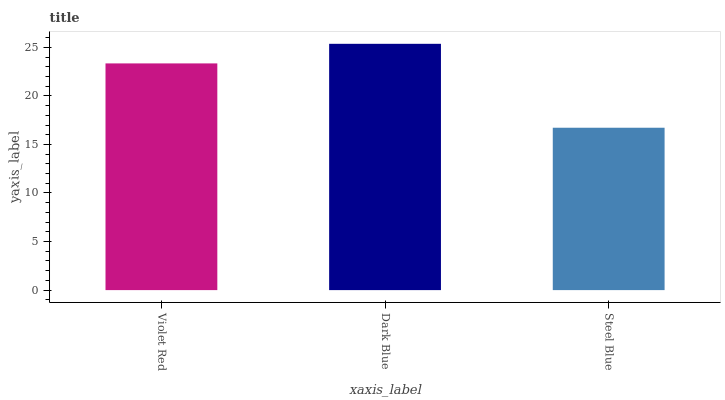Is Dark Blue the minimum?
Answer yes or no. No. Is Steel Blue the maximum?
Answer yes or no. No. Is Dark Blue greater than Steel Blue?
Answer yes or no. Yes. Is Steel Blue less than Dark Blue?
Answer yes or no. Yes. Is Steel Blue greater than Dark Blue?
Answer yes or no. No. Is Dark Blue less than Steel Blue?
Answer yes or no. No. Is Violet Red the high median?
Answer yes or no. Yes. Is Violet Red the low median?
Answer yes or no. Yes. Is Steel Blue the high median?
Answer yes or no. No. Is Dark Blue the low median?
Answer yes or no. No. 